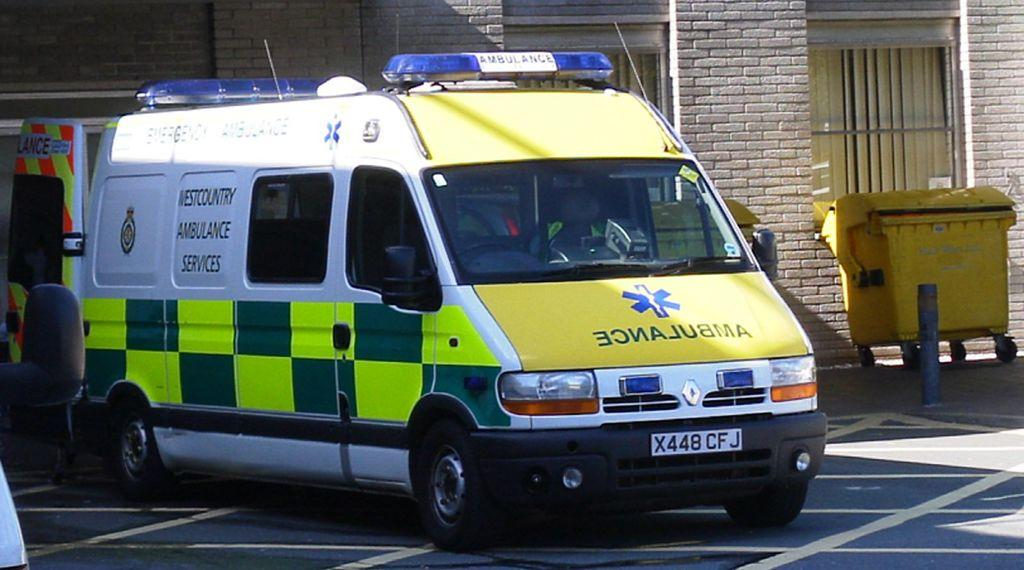What is the main subject of the image? There is a vehicle in the image. Where is the vehicle located? The vehicle is on the road. From where was the image taken? The image was taken from a window of a building. What features can be seen on the vehicle? The vehicle has headlights and a number plate. What type of magic is being performed by the truck in the image? There is no truck present in the image, and therefore no magic can be observed. 